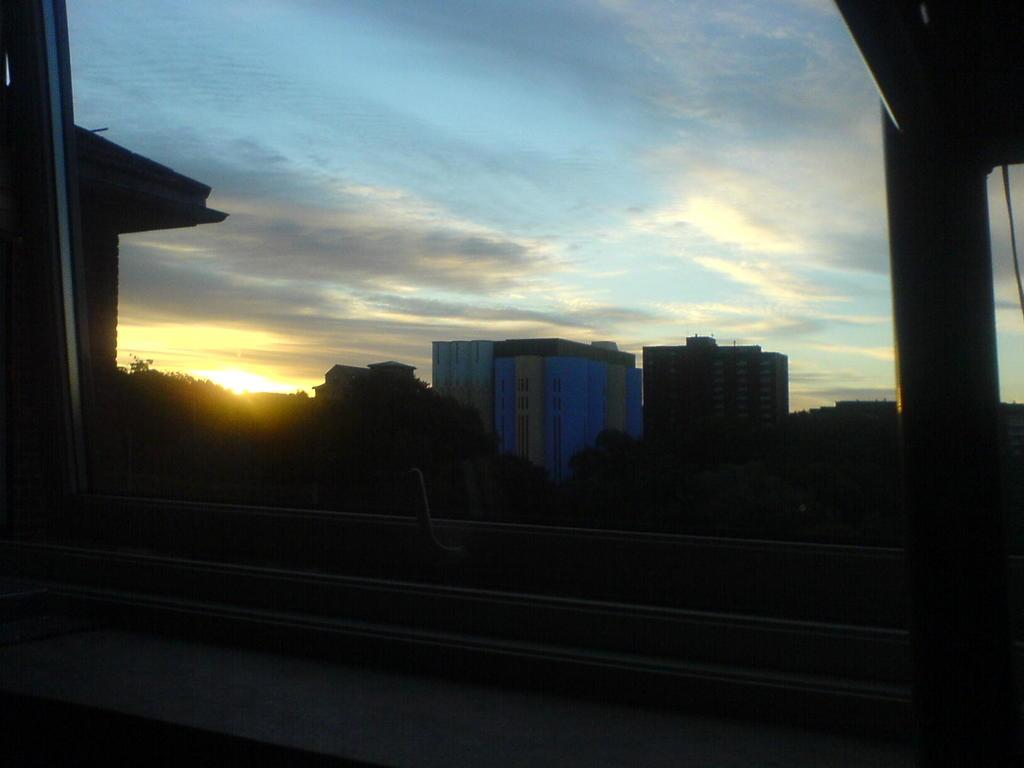What can be seen through the window in the image? Trees, a building, and the sky are visible through the window in the image. What is the condition of the sky in the image? The sky is cloudy in the image. How many pears can be seen in the hand of the person in the image? There is no person or hand visible in the image, and therefore no pears can be seen. 